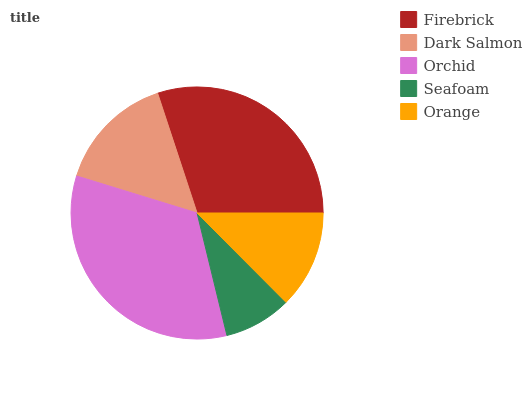Is Seafoam the minimum?
Answer yes or no. Yes. Is Orchid the maximum?
Answer yes or no. Yes. Is Dark Salmon the minimum?
Answer yes or no. No. Is Dark Salmon the maximum?
Answer yes or no. No. Is Firebrick greater than Dark Salmon?
Answer yes or no. Yes. Is Dark Salmon less than Firebrick?
Answer yes or no. Yes. Is Dark Salmon greater than Firebrick?
Answer yes or no. No. Is Firebrick less than Dark Salmon?
Answer yes or no. No. Is Dark Salmon the high median?
Answer yes or no. Yes. Is Dark Salmon the low median?
Answer yes or no. Yes. Is Seafoam the high median?
Answer yes or no. No. Is Seafoam the low median?
Answer yes or no. No. 